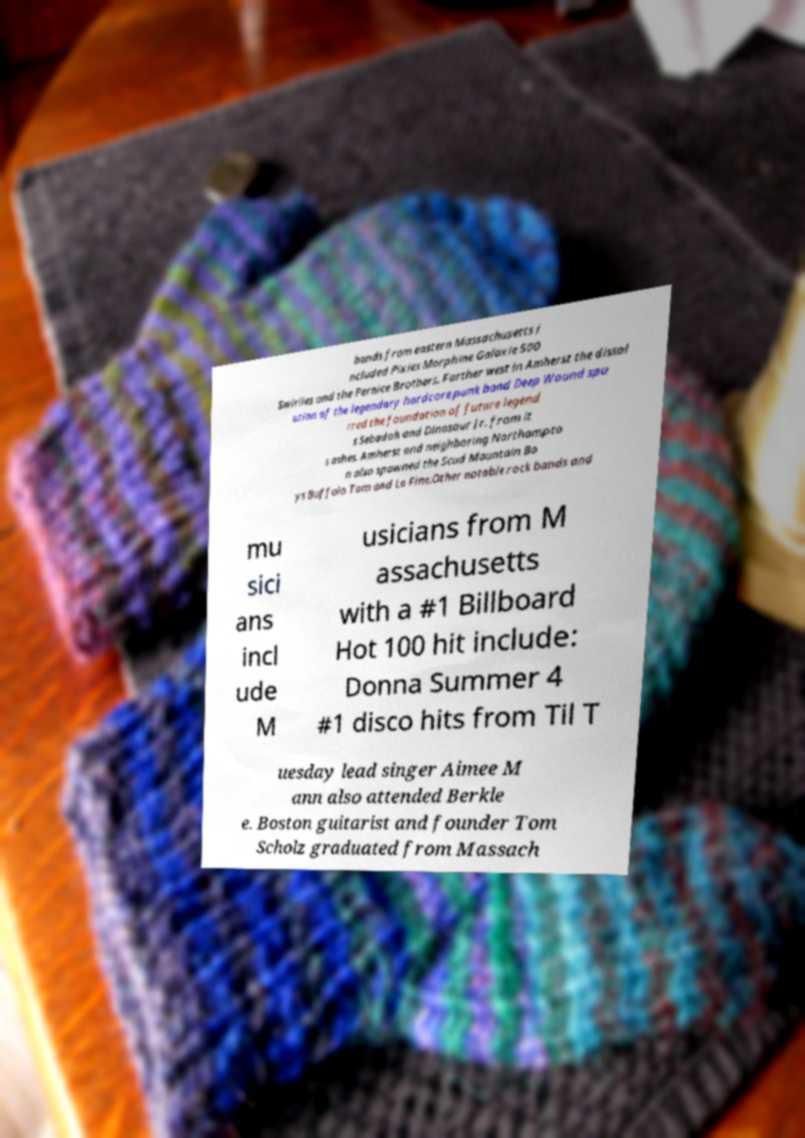There's text embedded in this image that I need extracted. Can you transcribe it verbatim? bands from eastern Massachusetts i ncluded Pixies Morphine Galaxie 500 Swirlies and the Pernice Brothers. Farther west in Amherst the dissol ution of the legendary hardcore punk band Deep Wound spu rred the foundation of future legend s Sebadoh and Dinosaur Jr. from it s ashes. Amherst and neighboring Northampto n also spawned the Scud Mountain Bo ys Buffalo Tom and Lo Fine.Other notable rock bands and mu sici ans incl ude M usicians from M assachusetts with a #1 Billboard Hot 100 hit include: Donna Summer 4 #1 disco hits from Til T uesday lead singer Aimee M ann also attended Berkle e. Boston guitarist and founder Tom Scholz graduated from Massach 